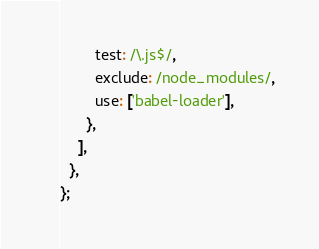Convert code to text. <code><loc_0><loc_0><loc_500><loc_500><_JavaScript_>        test: /\.js$/,
        exclude: /node_modules/,
        use: ['babel-loader'],
      },
    ],
  },
};
</code> 